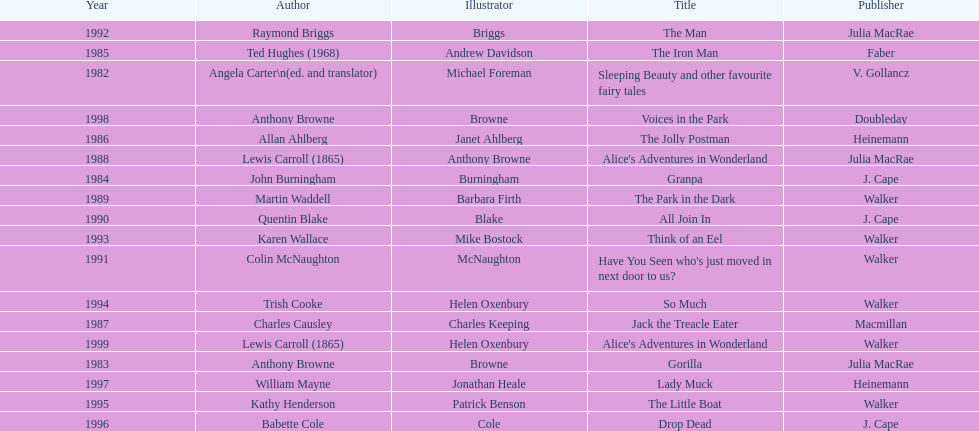How many total titles were published by walker? 5. 